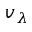<formula> <loc_0><loc_0><loc_500><loc_500>v _ { \lambda }</formula> 